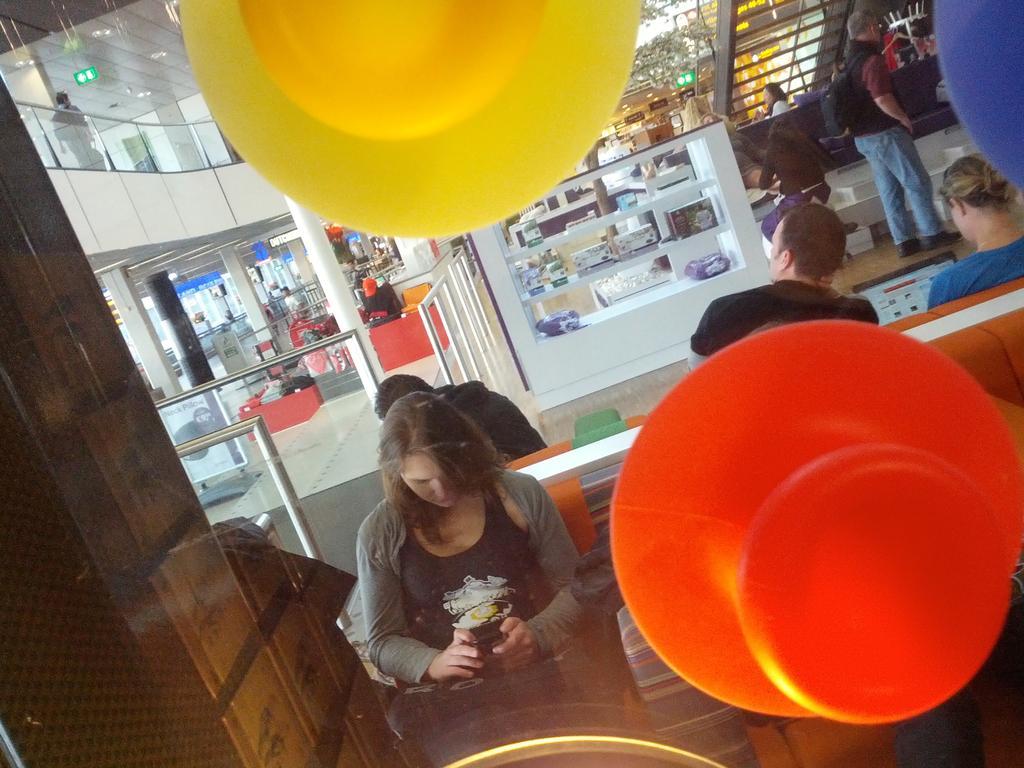Describe this image in one or two sentences. In this picture we can see three objects on the transparent glass. Behind the transparent glass, there are groups of people, pillars, glass rails, a tree, boards and some objects. In the top left corner of the image, there are ceiling lights. 